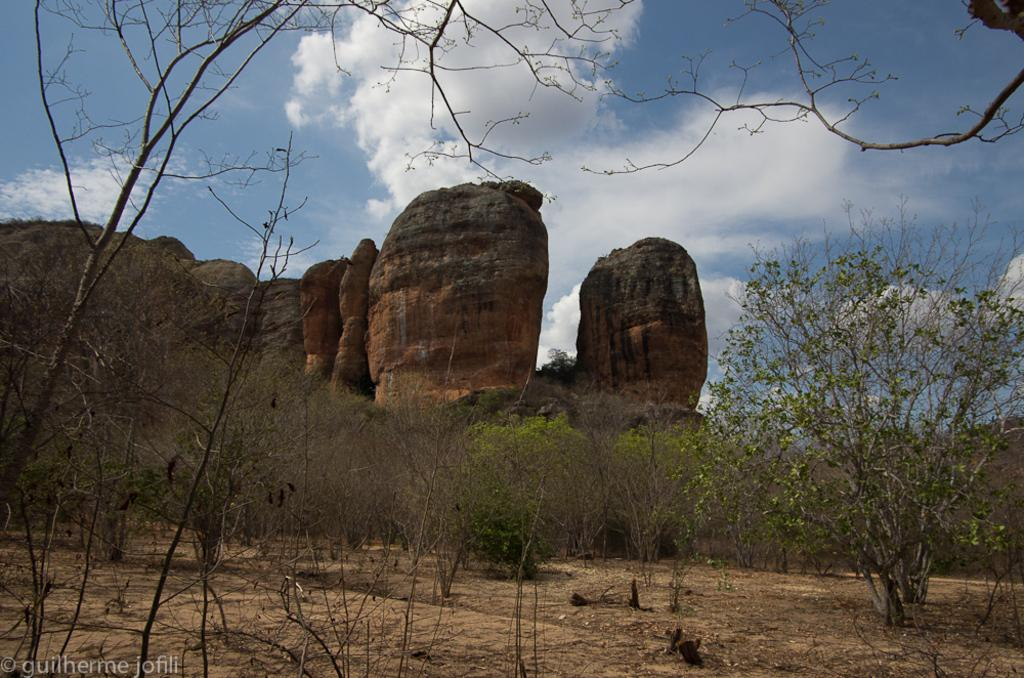What type of vegetation is at the bottom of the image? There are trees at the bottom of the image. What geological features are present in the middle of the image? There are big rocks in the middle of the image. What is visible at the top of the image? The sky is visible at the top of the image. What is the weather condition in the image? The sky appears to be cloudy, suggesting a potentially overcast or rainy day. Can you see any feet in the image? There are no feet visible in the image; it primarily features trees, rocks, and the sky. Is there a good-bye message written on any of the rocks in the image? There is no good-bye message present in the image; it only contains trees, rocks, and the sky. 